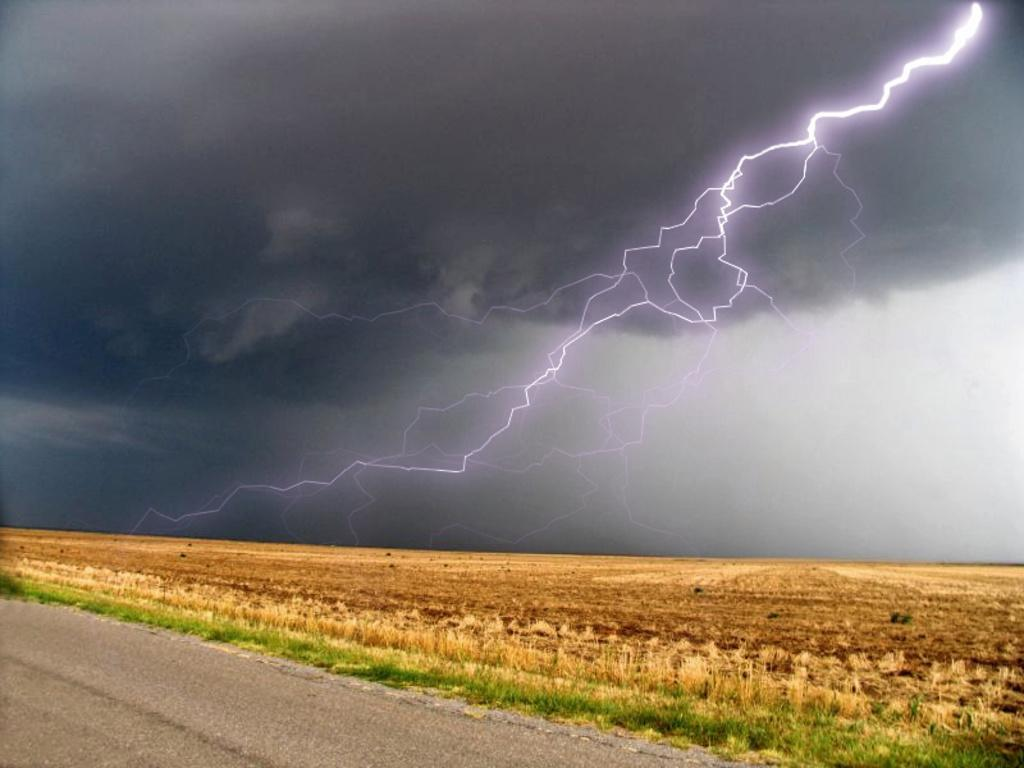What type of surface can be seen in the image? There is a road in the image. What type of vegetation is present on the ground? There is grass on the ground. What part of the natural environment is visible in the image? The sky is visible in the image. What letter is written on the road in the image? There is no letter written on the road in the image. Can you see a house in the image? There is no house present in the image. 